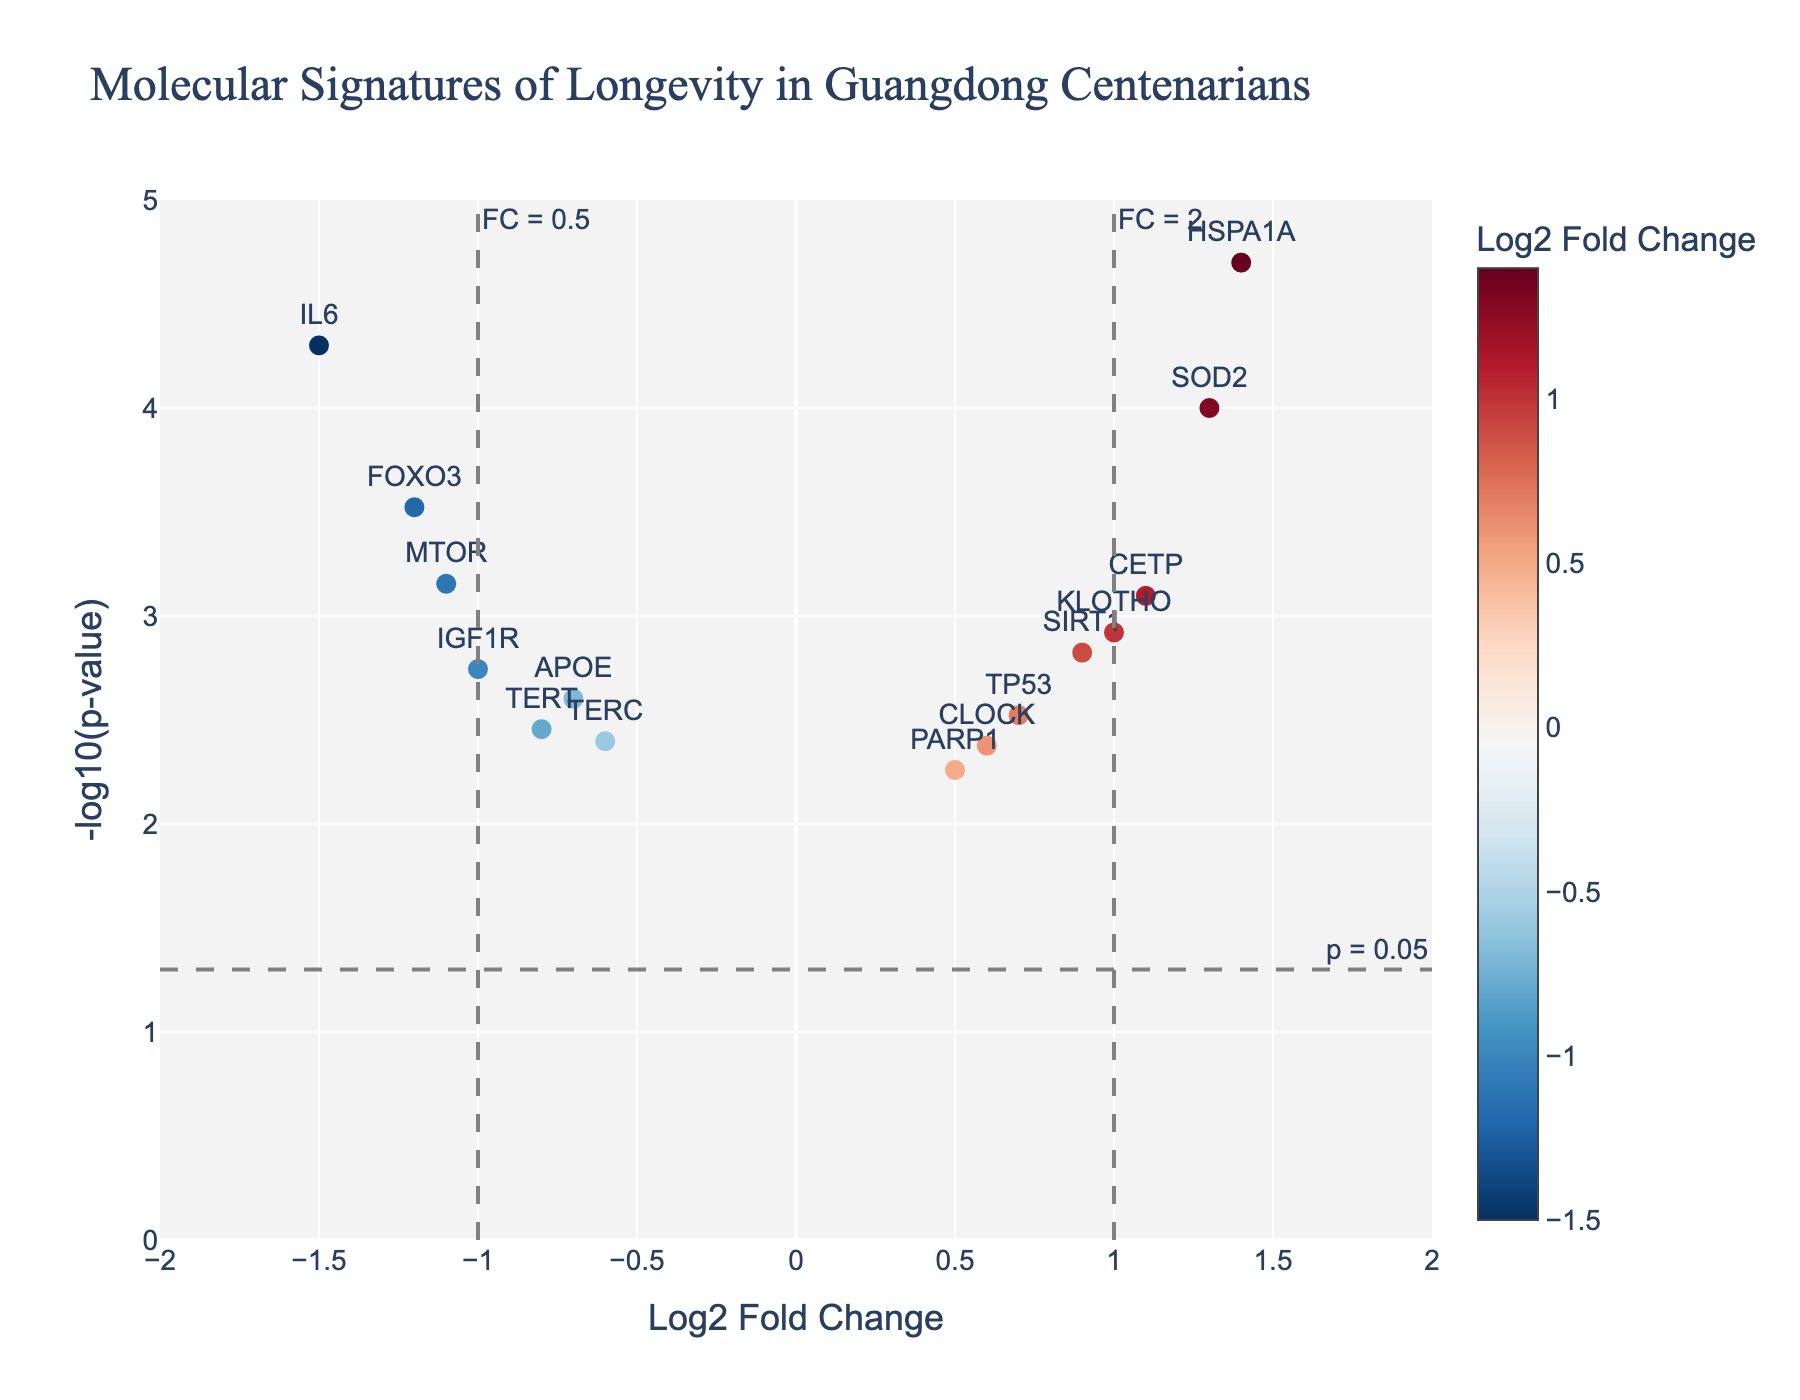What is the title of the plot? The title can be found at the top of the plot. According to the instructions and data provided, it should be labeled as "Molecular Signatures of Longevity in Guangdong Centenarians".
Answer: Molecular Signatures of Longevity in Guangdong Centenarians How many genes show a positive Log2 Fold Change? In the plot, genes with a positive Log2 Fold Change are plotted to the right of the vertical line at x=0. Counting the markers: SIRT1, CETP, SOD2, HSPA1A, TP53, KLOTHO, CLOCK, and PARP1 show positive values.
Answer: 8 Which gene has the smallest p-value? To find the gene with the smallest p-value, look for the highest point on the y-axis because -log10(p-value) is plotted. The gene HSPA1A stands at the highest point in the plot.
Answer: HSPA1A What are the Log2 Fold Change and p-value of the gene FOXO3? To find the values for FOXO3, locate the marker labeled "FOXO3". In the plot data, FOXO3 has a Log2 Fold Change of -1.2 and a p-value of 0.0003.
Answer: Log2FC: -1.2, p-value: 0.0003 How many genes have a Log2 Fold Change greater than 1 and are statistically significant (p-value < 0.05)? Look for genes that are right of the x=1 line (Log2 Fold Change > 1) and above the horizontal line at -log10(0.05). SOD2, HSPA1A, and CETP meet these criteria.
Answer: 3 Which gene has the highest negative Log2 Fold Change? The gene with the most negative Log2 Fold Change will be the farthest to the left on the x-axis. MTOR is the gene with the farthest negative Log2 Fold Change value of -1.1.
Answer: MTOR How many genes have a p-value less than 0.001? Genes with a p-value less than 0.001 are above the y-line at -log10(0.001). The genes are FOXO3, CETP, IL6, HSPA1A, MTOR, and SOD2.
Answer: 6 Which gene is both highly significant (p-value < 0.001) and has a Log2 Fold Change between -1 and 1? Highly significant genes are above the y-line at -log10(0.001). Look for genes within the range -1 to 1 on the x-axis. CETP and MTOR are identified, but only CETP falls within the range.
Answer: CETP What are the colors representing in this plot? The color scale, which spans from blue to red, represents the Log2 Fold Change values. Genes with lower values are blue, those with higher values are red, and the gradient indicates intermediate values.
Answer: Log2 Fold Change 